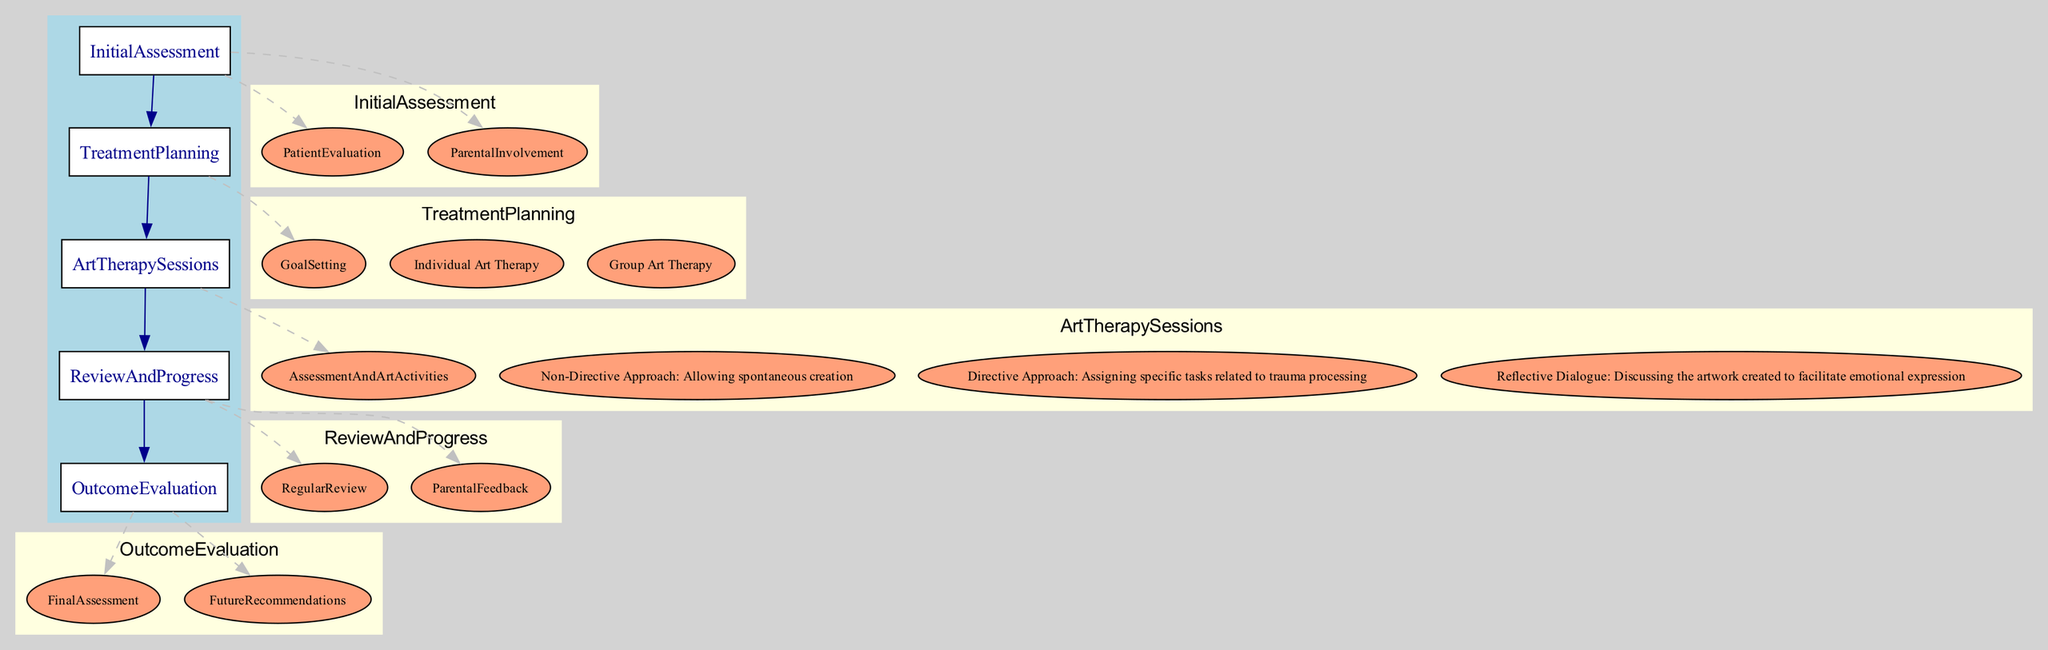What is the first step in the clinical pathway? The first step in the clinical pathway is "Initial Assessment," which is the starting stage identified in the diagram.
Answer: Initial Assessment How many therapy modalities are listed? The treatment planning section lists two therapy modalities. Counting them gives us the total, which are "Individual Art Therapy" and "Group Art Therapy."
Answer: 2 What is the primary focus of the 'Goal Setting' phase? The goal setting phase primarily focuses on "emotional expression and trauma resolution," which is stated in the treatment planning section.
Answer: Emotional expression and trauma resolution What does the 'Reflective Dialogue' technique involve? The 'Reflective Dialogue' technique involves "discussing the artwork created to facilitate emotional expression," which is explained in the therapeutic techniques.
Answer: Discussing the artwork created to facilitate emotional expression Which stage involves regular feedback sessions with parents? The stage that involves "regular feedback sessions with parents or caregivers" is the "Review And Progress" stage, according to the diagram.
Answer: Review And Progress How often are the reviews conducted in the 'Review And Progress' stage? The reviews are conducted "bi-weekly," as specified in the "Regular Review" component of the Review And Progress stage.
Answer: Bi-weekly What are the two types of Art Therapy sessions mentioned? The two types of Art Therapy sessions mentioned are "Individual Art Therapy" and "Group Art Therapy," outlined in the treatment planning section.
Answer: Individual Art Therapy, Group Art Therapy What does the 'Final Assessment' entail? The 'Final Assessment' entails a "re-evaluation of the child's psychological state and symptoms post-therapy," as described in the outcome evaluation stage.
Answer: Re-evaluation of the child's psychological state and symptoms post-therapy How many therapeutic techniques are listed under 'Therapeutic Techniques'? There are three therapeutic techniques listed, which include "Non-Directive Approach," "Directive Approach," and "Reflective Dialogue." Counting these gives us the total number of techniques.
Answer: 3 